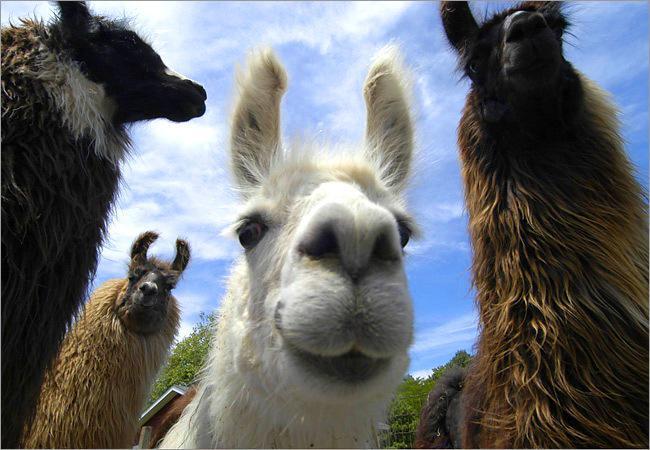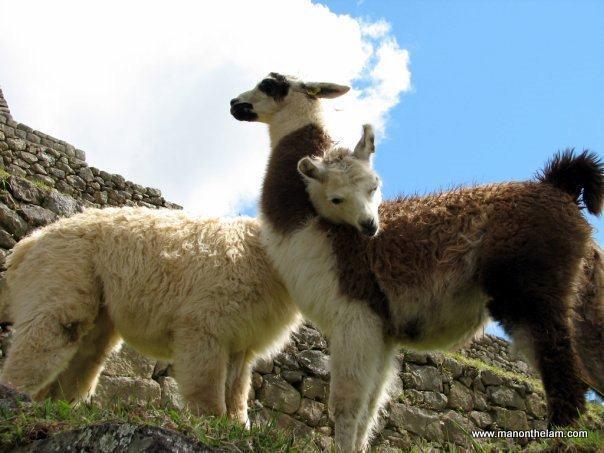The first image is the image on the left, the second image is the image on the right. For the images displayed, is the sentence "There are exactly four llamas." factually correct? Answer yes or no. No. The first image is the image on the left, the second image is the image on the right. Assess this claim about the two images: "Each image shows exactly two llamas posed close together in the foreground, and a mountain peak is visible in the background of the left image.". Correct or not? Answer yes or no. No. 